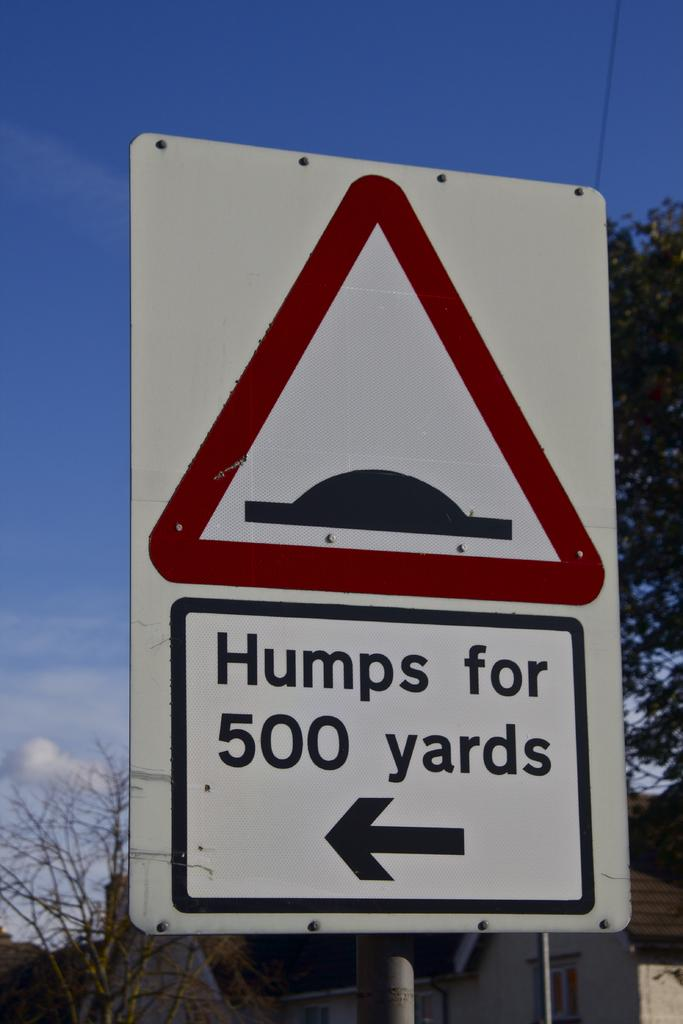<image>
Offer a succinct explanation of the picture presented. A street sign warns drivers that there are speed bumps for 500 yards, in the direction of an arrow that is pointing left. 